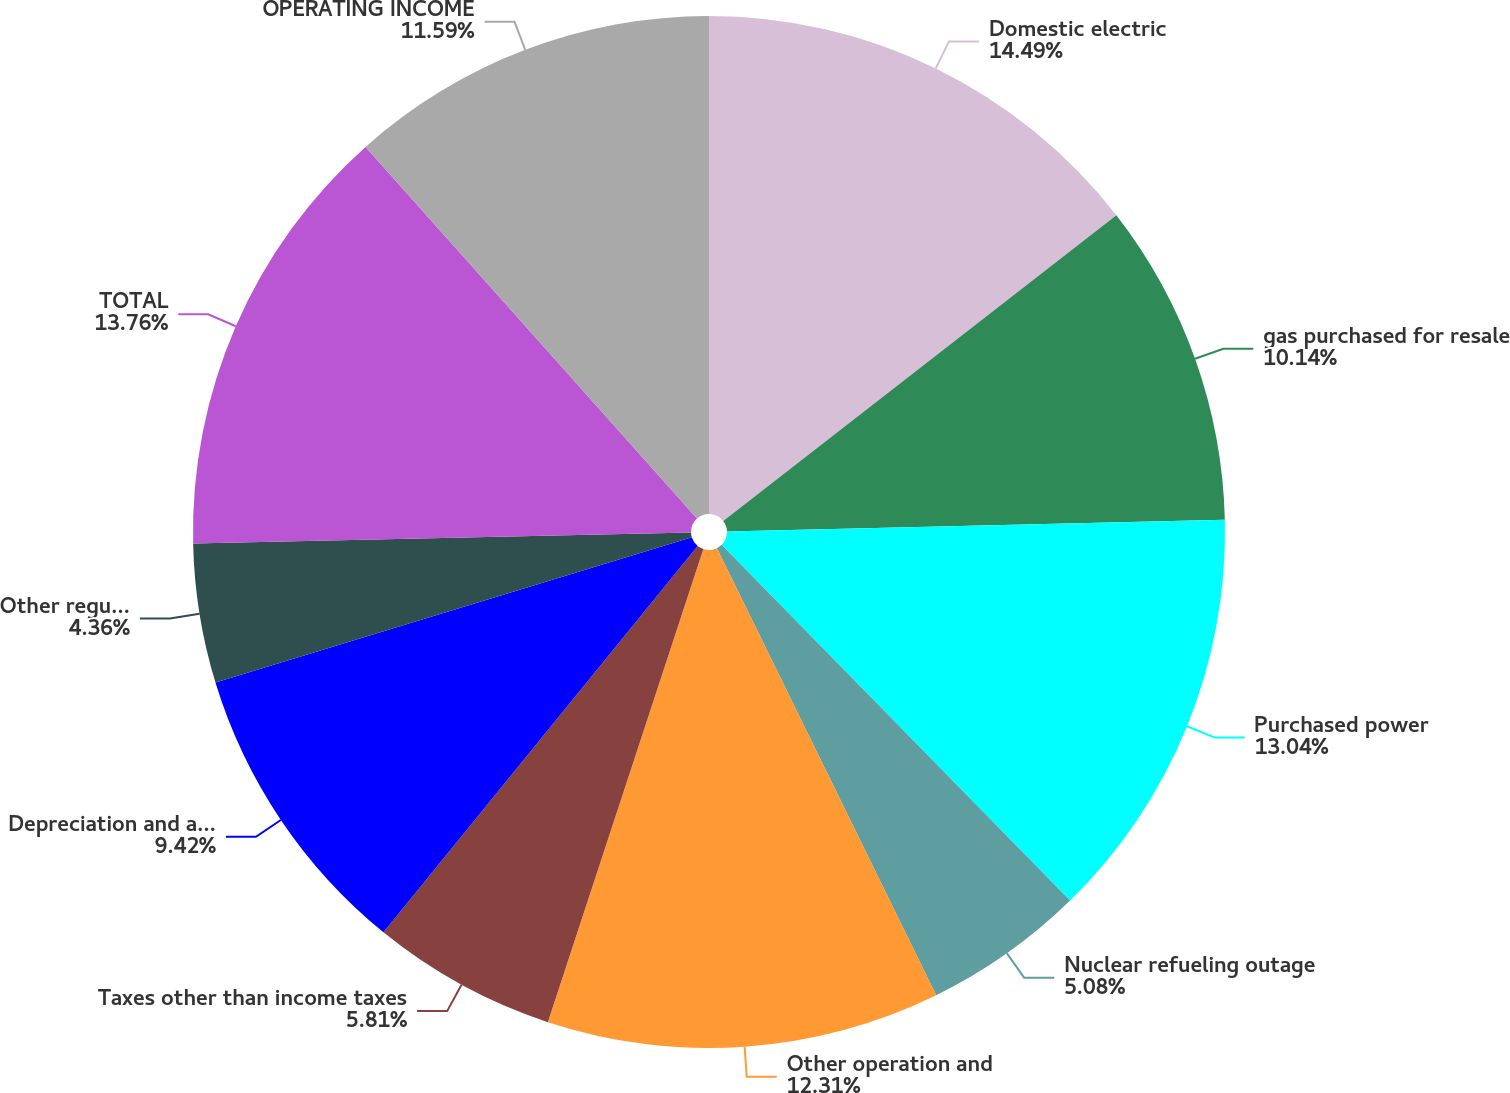Convert chart to OTSL. <chart><loc_0><loc_0><loc_500><loc_500><pie_chart><fcel>Domestic electric<fcel>gas purchased for resale<fcel>Purchased power<fcel>Nuclear refueling outage<fcel>Other operation and<fcel>Taxes other than income taxes<fcel>Depreciation and amortization<fcel>Other regulatory credits - net<fcel>TOTAL<fcel>OPERATING INCOME<nl><fcel>14.48%<fcel>10.14%<fcel>13.04%<fcel>5.08%<fcel>12.31%<fcel>5.81%<fcel>9.42%<fcel>4.36%<fcel>13.76%<fcel>11.59%<nl></chart> 